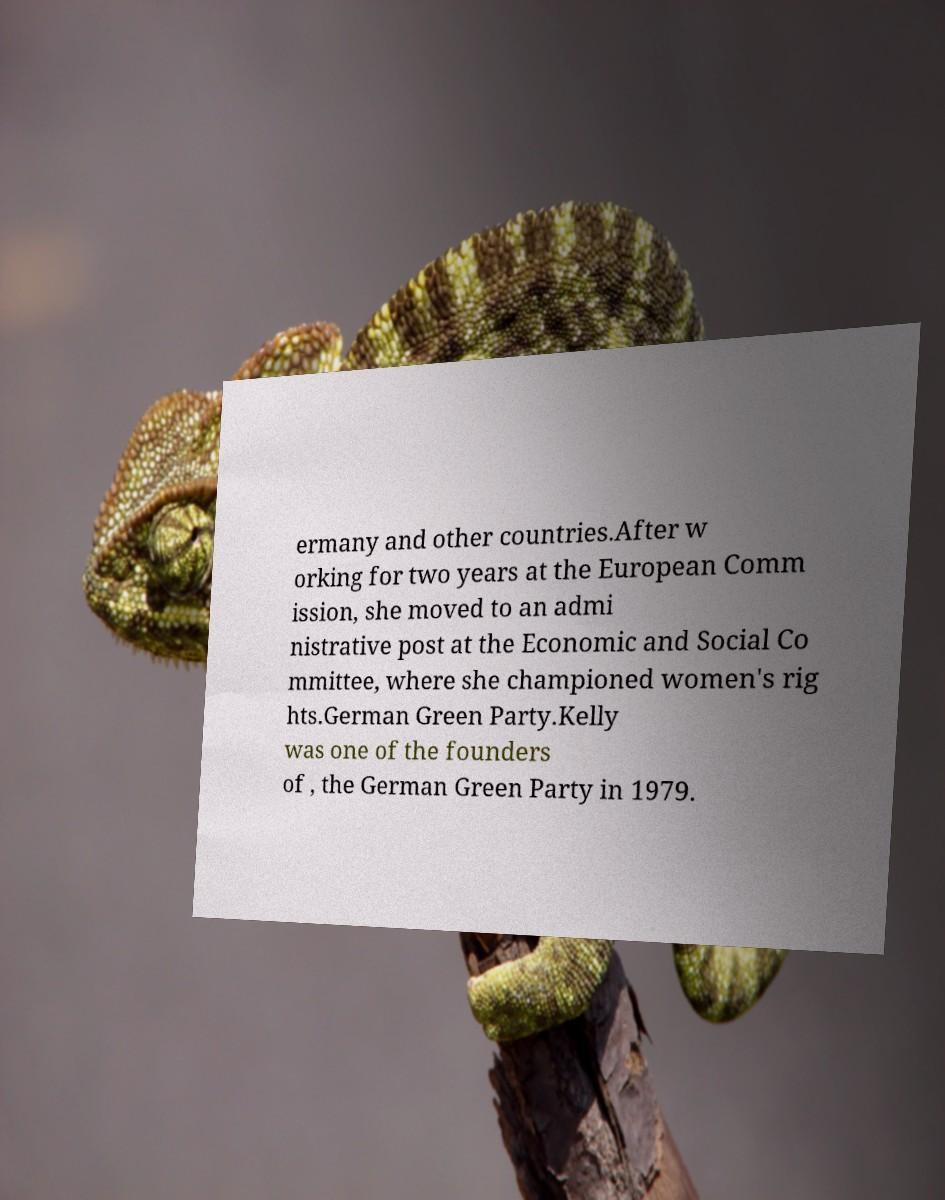Please read and relay the text visible in this image. What does it say? ermany and other countries.After w orking for two years at the European Comm ission, she moved to an admi nistrative post at the Economic and Social Co mmittee, where she championed women's rig hts.German Green Party.Kelly was one of the founders of , the German Green Party in 1979. 